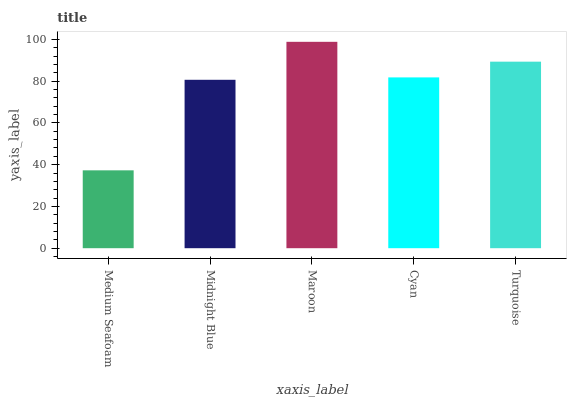Is Medium Seafoam the minimum?
Answer yes or no. Yes. Is Maroon the maximum?
Answer yes or no. Yes. Is Midnight Blue the minimum?
Answer yes or no. No. Is Midnight Blue the maximum?
Answer yes or no. No. Is Midnight Blue greater than Medium Seafoam?
Answer yes or no. Yes. Is Medium Seafoam less than Midnight Blue?
Answer yes or no. Yes. Is Medium Seafoam greater than Midnight Blue?
Answer yes or no. No. Is Midnight Blue less than Medium Seafoam?
Answer yes or no. No. Is Cyan the high median?
Answer yes or no. Yes. Is Cyan the low median?
Answer yes or no. Yes. Is Turquoise the high median?
Answer yes or no. No. Is Medium Seafoam the low median?
Answer yes or no. No. 